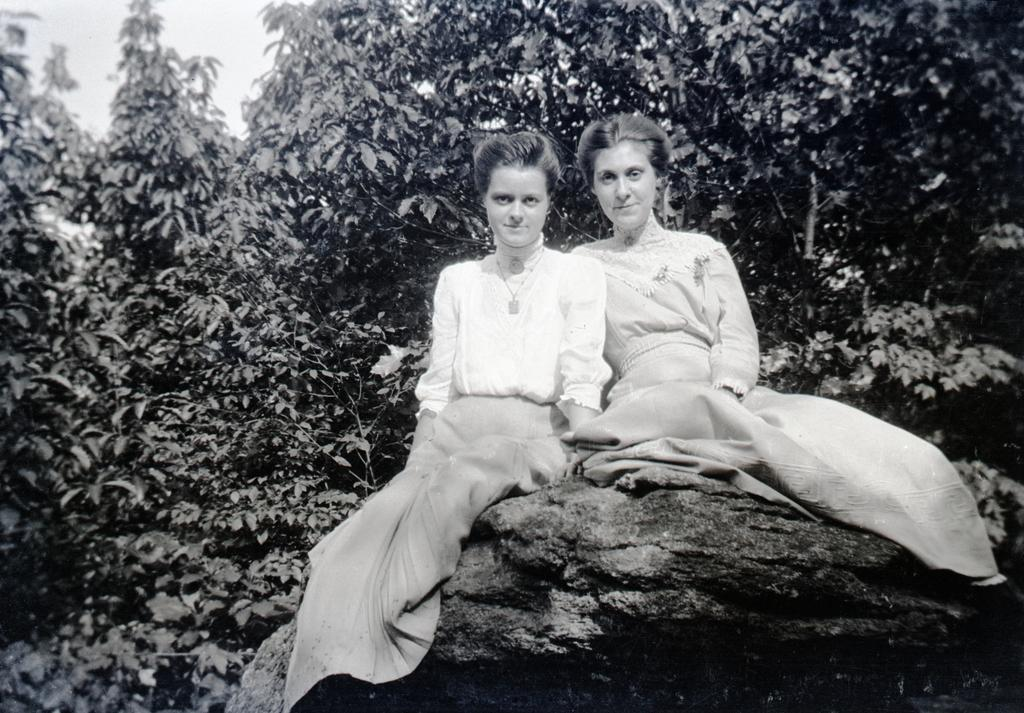How many people are in the image? There are two women in the image. What are the women doing in the image? The women are sitting on a rock. What can be seen in the background of the image? Plants and the sky are visible in the background of the image. What type of knot is the woman on the left using to secure her hat in the image? There is no knot or hat visible in the image; the women are simply sitting on a rock. 